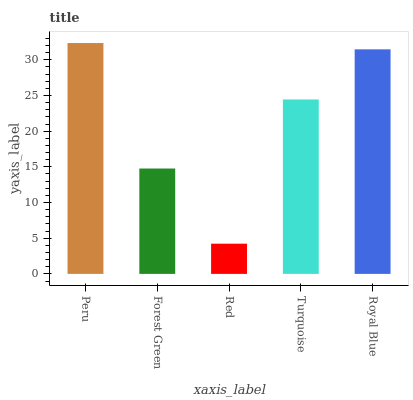Is Red the minimum?
Answer yes or no. Yes. Is Peru the maximum?
Answer yes or no. Yes. Is Forest Green the minimum?
Answer yes or no. No. Is Forest Green the maximum?
Answer yes or no. No. Is Peru greater than Forest Green?
Answer yes or no. Yes. Is Forest Green less than Peru?
Answer yes or no. Yes. Is Forest Green greater than Peru?
Answer yes or no. No. Is Peru less than Forest Green?
Answer yes or no. No. Is Turquoise the high median?
Answer yes or no. Yes. Is Turquoise the low median?
Answer yes or no. Yes. Is Royal Blue the high median?
Answer yes or no. No. Is Forest Green the low median?
Answer yes or no. No. 